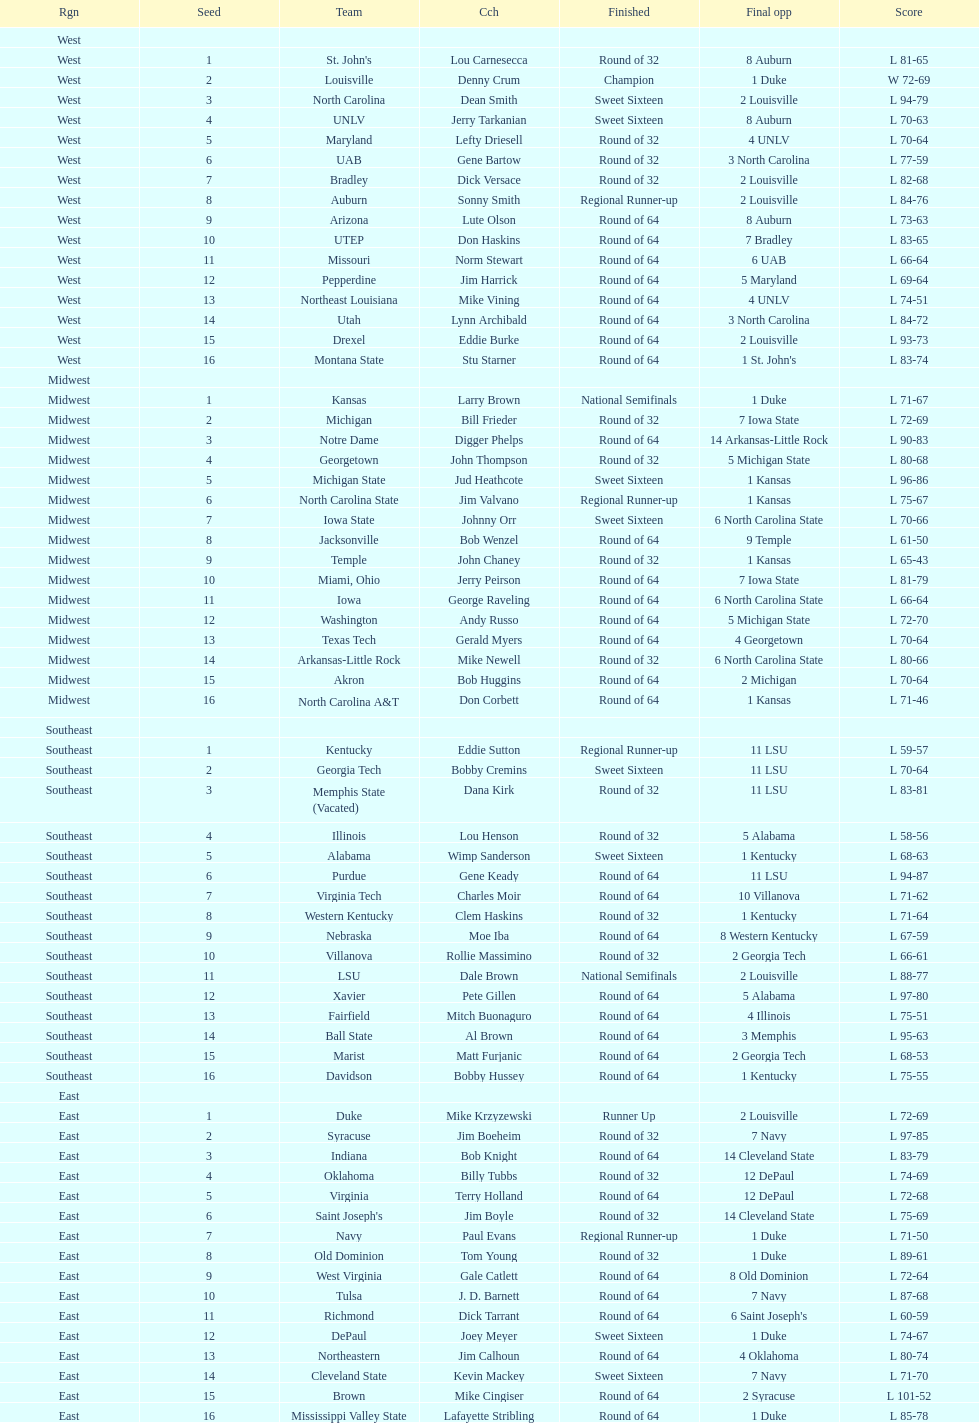Who is the only team from the east region to reach the final round? Duke. Could you parse the entire table? {'header': ['Rgn', 'Seed', 'Team', 'Cch', 'Finished', 'Final opp', 'Score'], 'rows': [['West', '', '', '', '', '', ''], ['West', '1', "St. John's", 'Lou Carnesecca', 'Round of 32', '8 Auburn', 'L 81-65'], ['West', '2', 'Louisville', 'Denny Crum', 'Champion', '1 Duke', 'W 72-69'], ['West', '3', 'North Carolina', 'Dean Smith', 'Sweet Sixteen', '2 Louisville', 'L 94-79'], ['West', '4', 'UNLV', 'Jerry Tarkanian', 'Sweet Sixteen', '8 Auburn', 'L 70-63'], ['West', '5', 'Maryland', 'Lefty Driesell', 'Round of 32', '4 UNLV', 'L 70-64'], ['West', '6', 'UAB', 'Gene Bartow', 'Round of 32', '3 North Carolina', 'L 77-59'], ['West', '7', 'Bradley', 'Dick Versace', 'Round of 32', '2 Louisville', 'L 82-68'], ['West', '8', 'Auburn', 'Sonny Smith', 'Regional Runner-up', '2 Louisville', 'L 84-76'], ['West', '9', 'Arizona', 'Lute Olson', 'Round of 64', '8 Auburn', 'L 73-63'], ['West', '10', 'UTEP', 'Don Haskins', 'Round of 64', '7 Bradley', 'L 83-65'], ['West', '11', 'Missouri', 'Norm Stewart', 'Round of 64', '6 UAB', 'L 66-64'], ['West', '12', 'Pepperdine', 'Jim Harrick', 'Round of 64', '5 Maryland', 'L 69-64'], ['West', '13', 'Northeast Louisiana', 'Mike Vining', 'Round of 64', '4 UNLV', 'L 74-51'], ['West', '14', 'Utah', 'Lynn Archibald', 'Round of 64', '3 North Carolina', 'L 84-72'], ['West', '15', 'Drexel', 'Eddie Burke', 'Round of 64', '2 Louisville', 'L 93-73'], ['West', '16', 'Montana State', 'Stu Starner', 'Round of 64', "1 St. John's", 'L 83-74'], ['Midwest', '', '', '', '', '', ''], ['Midwest', '1', 'Kansas', 'Larry Brown', 'National Semifinals', '1 Duke', 'L 71-67'], ['Midwest', '2', 'Michigan', 'Bill Frieder', 'Round of 32', '7 Iowa State', 'L 72-69'], ['Midwest', '3', 'Notre Dame', 'Digger Phelps', 'Round of 64', '14 Arkansas-Little Rock', 'L 90-83'], ['Midwest', '4', 'Georgetown', 'John Thompson', 'Round of 32', '5 Michigan State', 'L 80-68'], ['Midwest', '5', 'Michigan State', 'Jud Heathcote', 'Sweet Sixteen', '1 Kansas', 'L 96-86'], ['Midwest', '6', 'North Carolina State', 'Jim Valvano', 'Regional Runner-up', '1 Kansas', 'L 75-67'], ['Midwest', '7', 'Iowa State', 'Johnny Orr', 'Sweet Sixteen', '6 North Carolina State', 'L 70-66'], ['Midwest', '8', 'Jacksonville', 'Bob Wenzel', 'Round of 64', '9 Temple', 'L 61-50'], ['Midwest', '9', 'Temple', 'John Chaney', 'Round of 32', '1 Kansas', 'L 65-43'], ['Midwest', '10', 'Miami, Ohio', 'Jerry Peirson', 'Round of 64', '7 Iowa State', 'L 81-79'], ['Midwest', '11', 'Iowa', 'George Raveling', 'Round of 64', '6 North Carolina State', 'L 66-64'], ['Midwest', '12', 'Washington', 'Andy Russo', 'Round of 64', '5 Michigan State', 'L 72-70'], ['Midwest', '13', 'Texas Tech', 'Gerald Myers', 'Round of 64', '4 Georgetown', 'L 70-64'], ['Midwest', '14', 'Arkansas-Little Rock', 'Mike Newell', 'Round of 32', '6 North Carolina State', 'L 80-66'], ['Midwest', '15', 'Akron', 'Bob Huggins', 'Round of 64', '2 Michigan', 'L 70-64'], ['Midwest', '16', 'North Carolina A&T', 'Don Corbett', 'Round of 64', '1 Kansas', 'L 71-46'], ['Southeast', '', '', '', '', '', ''], ['Southeast', '1', 'Kentucky', 'Eddie Sutton', 'Regional Runner-up', '11 LSU', 'L 59-57'], ['Southeast', '2', 'Georgia Tech', 'Bobby Cremins', 'Sweet Sixteen', '11 LSU', 'L 70-64'], ['Southeast', '3', 'Memphis State (Vacated)', 'Dana Kirk', 'Round of 32', '11 LSU', 'L 83-81'], ['Southeast', '4', 'Illinois', 'Lou Henson', 'Round of 32', '5 Alabama', 'L 58-56'], ['Southeast', '5', 'Alabama', 'Wimp Sanderson', 'Sweet Sixteen', '1 Kentucky', 'L 68-63'], ['Southeast', '6', 'Purdue', 'Gene Keady', 'Round of 64', '11 LSU', 'L 94-87'], ['Southeast', '7', 'Virginia Tech', 'Charles Moir', 'Round of 64', '10 Villanova', 'L 71-62'], ['Southeast', '8', 'Western Kentucky', 'Clem Haskins', 'Round of 32', '1 Kentucky', 'L 71-64'], ['Southeast', '9', 'Nebraska', 'Moe Iba', 'Round of 64', '8 Western Kentucky', 'L 67-59'], ['Southeast', '10', 'Villanova', 'Rollie Massimino', 'Round of 32', '2 Georgia Tech', 'L 66-61'], ['Southeast', '11', 'LSU', 'Dale Brown', 'National Semifinals', '2 Louisville', 'L 88-77'], ['Southeast', '12', 'Xavier', 'Pete Gillen', 'Round of 64', '5 Alabama', 'L 97-80'], ['Southeast', '13', 'Fairfield', 'Mitch Buonaguro', 'Round of 64', '4 Illinois', 'L 75-51'], ['Southeast', '14', 'Ball State', 'Al Brown', 'Round of 64', '3 Memphis', 'L 95-63'], ['Southeast', '15', 'Marist', 'Matt Furjanic', 'Round of 64', '2 Georgia Tech', 'L 68-53'], ['Southeast', '16', 'Davidson', 'Bobby Hussey', 'Round of 64', '1 Kentucky', 'L 75-55'], ['East', '', '', '', '', '', ''], ['East', '1', 'Duke', 'Mike Krzyzewski', 'Runner Up', '2 Louisville', 'L 72-69'], ['East', '2', 'Syracuse', 'Jim Boeheim', 'Round of 32', '7 Navy', 'L 97-85'], ['East', '3', 'Indiana', 'Bob Knight', 'Round of 64', '14 Cleveland State', 'L 83-79'], ['East', '4', 'Oklahoma', 'Billy Tubbs', 'Round of 32', '12 DePaul', 'L 74-69'], ['East', '5', 'Virginia', 'Terry Holland', 'Round of 64', '12 DePaul', 'L 72-68'], ['East', '6', "Saint Joseph's", 'Jim Boyle', 'Round of 32', '14 Cleveland State', 'L 75-69'], ['East', '7', 'Navy', 'Paul Evans', 'Regional Runner-up', '1 Duke', 'L 71-50'], ['East', '8', 'Old Dominion', 'Tom Young', 'Round of 32', '1 Duke', 'L 89-61'], ['East', '9', 'West Virginia', 'Gale Catlett', 'Round of 64', '8 Old Dominion', 'L 72-64'], ['East', '10', 'Tulsa', 'J. D. Barnett', 'Round of 64', '7 Navy', 'L 87-68'], ['East', '11', 'Richmond', 'Dick Tarrant', 'Round of 64', "6 Saint Joseph's", 'L 60-59'], ['East', '12', 'DePaul', 'Joey Meyer', 'Sweet Sixteen', '1 Duke', 'L 74-67'], ['East', '13', 'Northeastern', 'Jim Calhoun', 'Round of 64', '4 Oklahoma', 'L 80-74'], ['East', '14', 'Cleveland State', 'Kevin Mackey', 'Sweet Sixteen', '7 Navy', 'L 71-70'], ['East', '15', 'Brown', 'Mike Cingiser', 'Round of 64', '2 Syracuse', 'L 101-52'], ['East', '16', 'Mississippi Valley State', 'Lafayette Stribling', 'Round of 64', '1 Duke', 'L 85-78']]} 